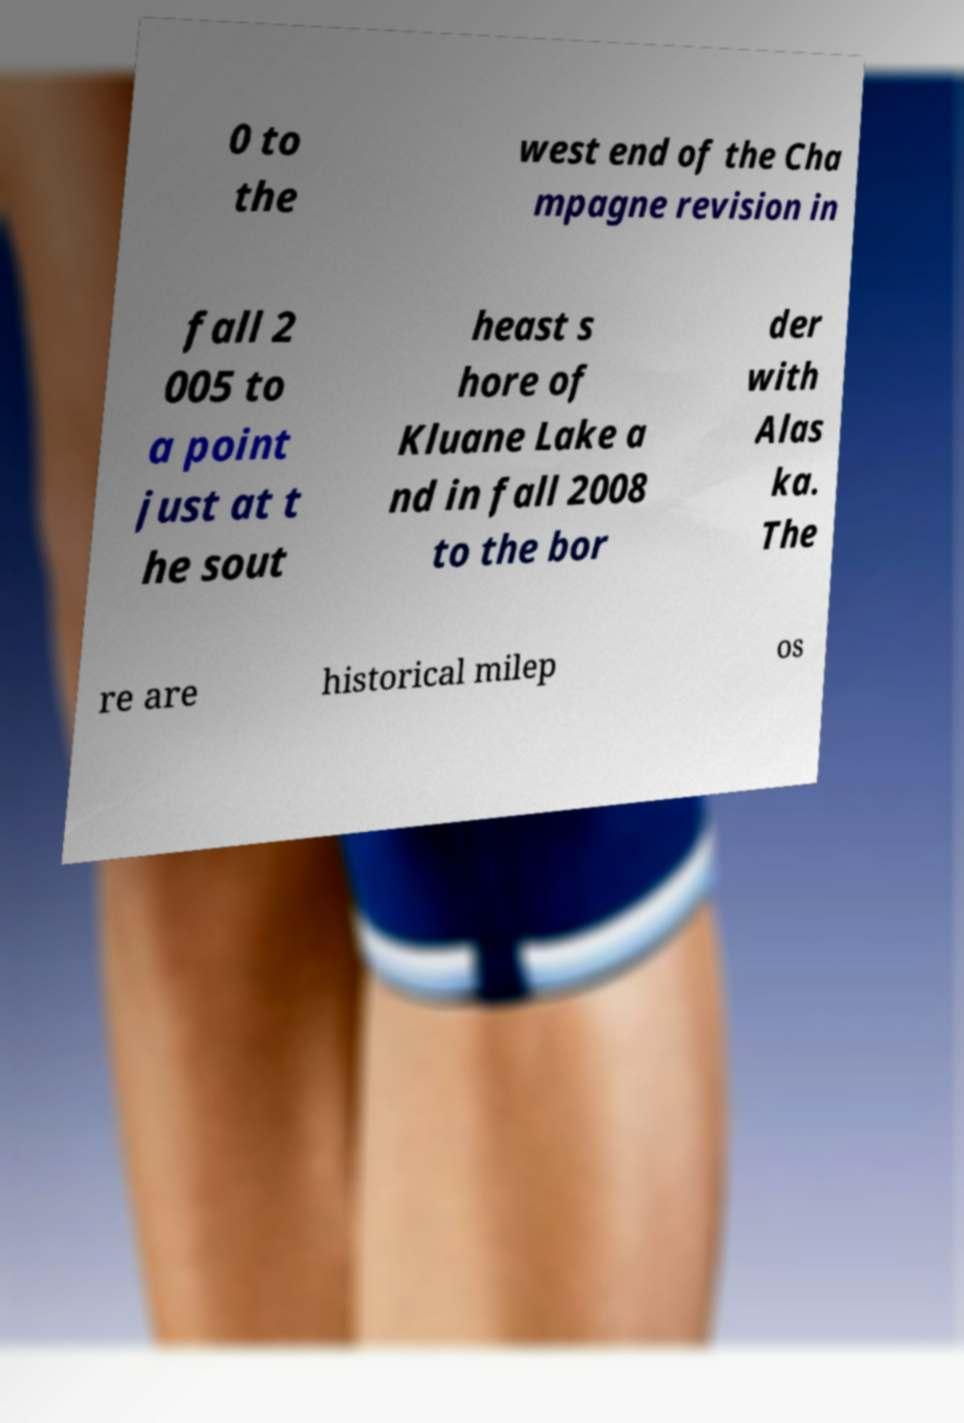Please identify and transcribe the text found in this image. 0 to the west end of the Cha mpagne revision in fall 2 005 to a point just at t he sout heast s hore of Kluane Lake a nd in fall 2008 to the bor der with Alas ka. The re are historical milep os 